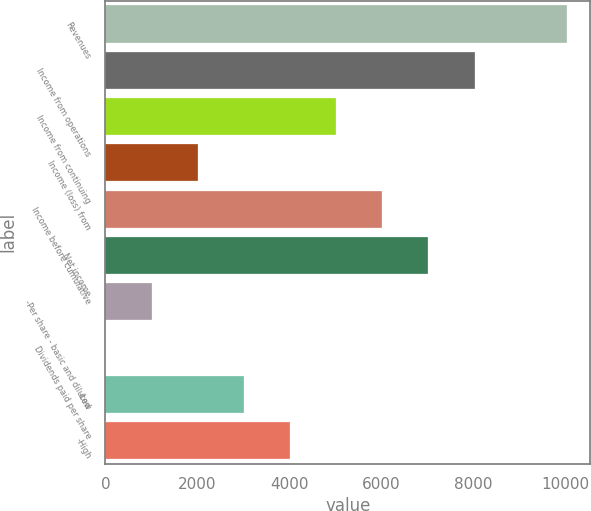<chart> <loc_0><loc_0><loc_500><loc_500><bar_chart><fcel>Revenues<fcel>Income from operations<fcel>Income from continuing<fcel>Income (loss) from<fcel>Income before cumulative<fcel>Net income<fcel>-Per share - basic and diluted<fcel>Dividends paid per share<fcel>-Low<fcel>-High<nl><fcel>10033<fcel>8026.47<fcel>5016.63<fcel>2006.79<fcel>6019.91<fcel>7023.19<fcel>1003.51<fcel>0.23<fcel>3010.07<fcel>4013.35<nl></chart> 